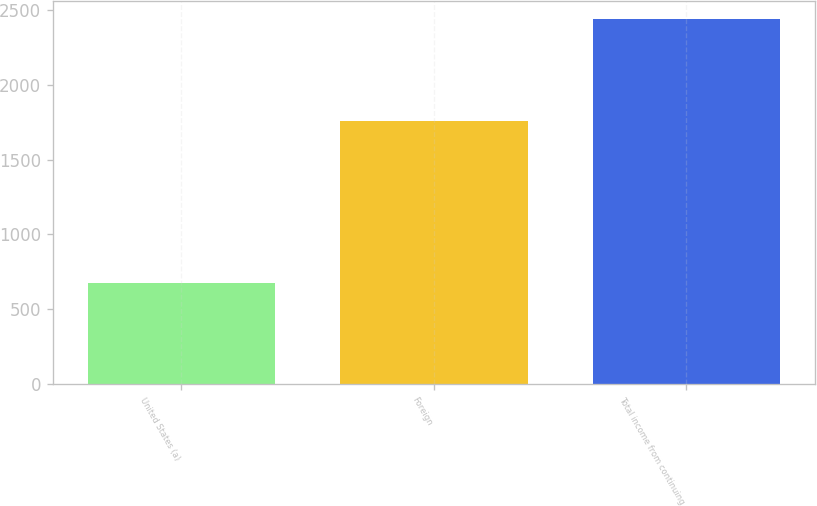Convert chart to OTSL. <chart><loc_0><loc_0><loc_500><loc_500><bar_chart><fcel>United States (a)<fcel>Foreign<fcel>Total income from continuing<nl><fcel>676<fcel>1760<fcel>2436<nl></chart> 